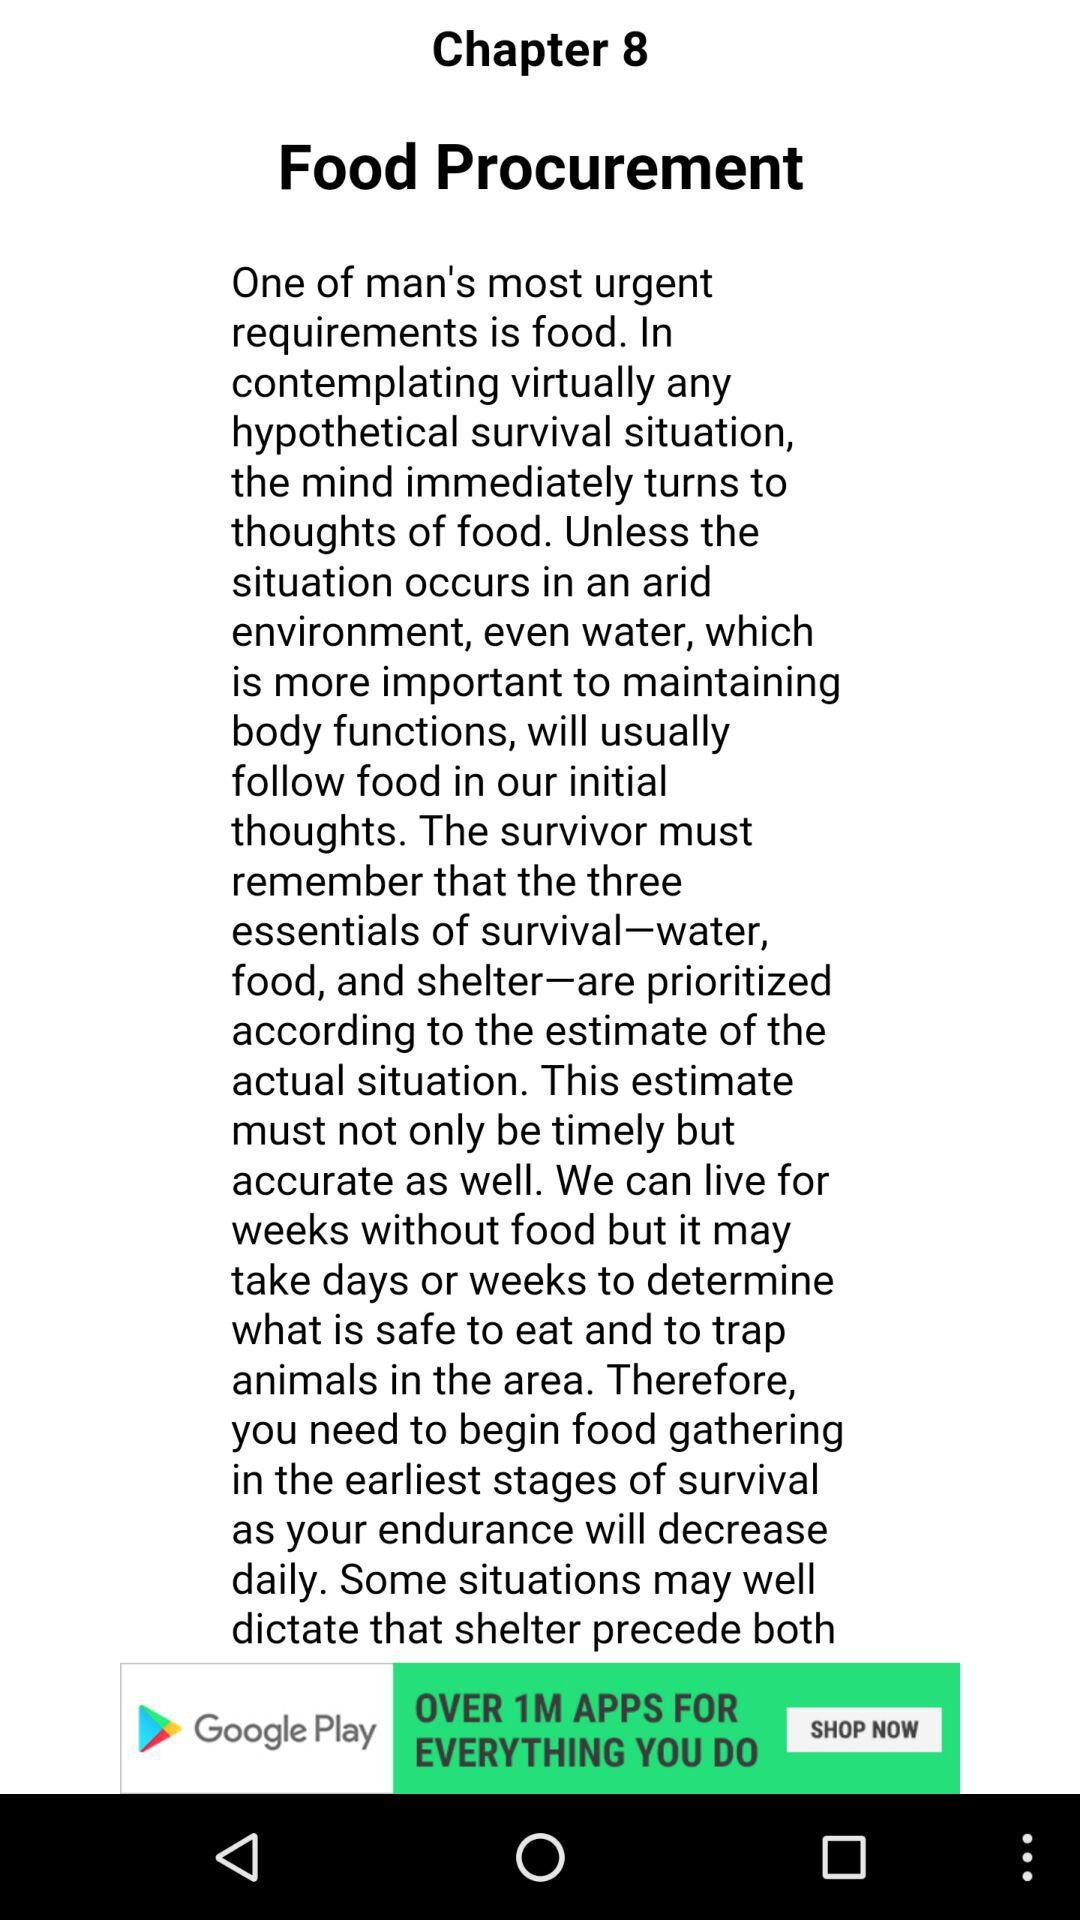What is the name of chapter 8? The name of chapter 8 is "Food Procurement". 